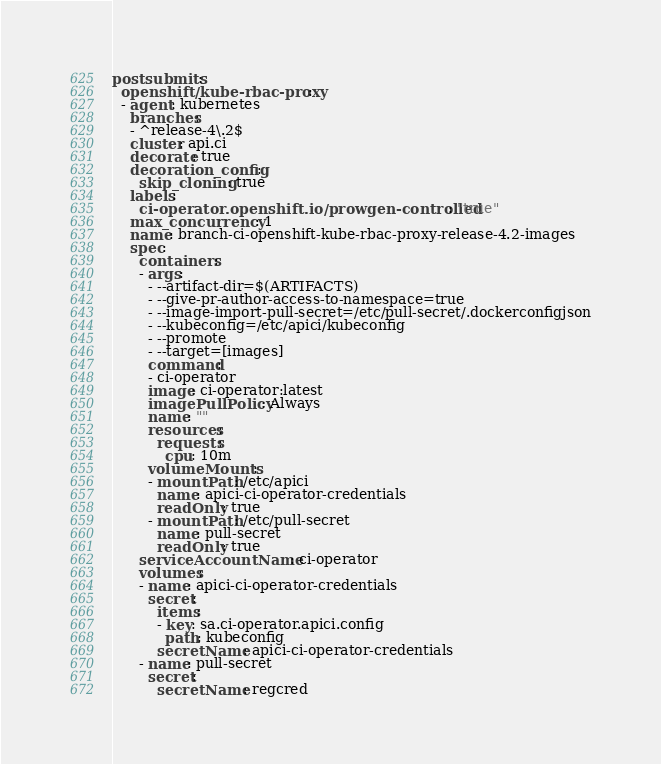Convert code to text. <code><loc_0><loc_0><loc_500><loc_500><_YAML_>postsubmits:
  openshift/kube-rbac-proxy:
  - agent: kubernetes
    branches:
    - ^release-4\.2$
    cluster: api.ci
    decorate: true
    decoration_config:
      skip_cloning: true
    labels:
      ci-operator.openshift.io/prowgen-controlled: "true"
    max_concurrency: 1
    name: branch-ci-openshift-kube-rbac-proxy-release-4.2-images
    spec:
      containers:
      - args:
        - --artifact-dir=$(ARTIFACTS)
        - --give-pr-author-access-to-namespace=true
        - --image-import-pull-secret=/etc/pull-secret/.dockerconfigjson
        - --kubeconfig=/etc/apici/kubeconfig
        - --promote
        - --target=[images]
        command:
        - ci-operator
        image: ci-operator:latest
        imagePullPolicy: Always
        name: ""
        resources:
          requests:
            cpu: 10m
        volumeMounts:
        - mountPath: /etc/apici
          name: apici-ci-operator-credentials
          readOnly: true
        - mountPath: /etc/pull-secret
          name: pull-secret
          readOnly: true
      serviceAccountName: ci-operator
      volumes:
      - name: apici-ci-operator-credentials
        secret:
          items:
          - key: sa.ci-operator.apici.config
            path: kubeconfig
          secretName: apici-ci-operator-credentials
      - name: pull-secret
        secret:
          secretName: regcred
</code> 